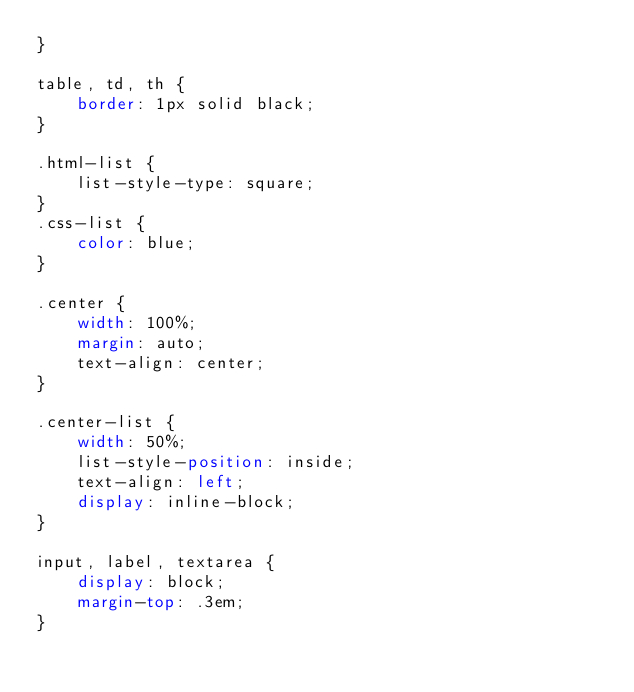Convert code to text. <code><loc_0><loc_0><loc_500><loc_500><_CSS_>}

table, td, th {
    border: 1px solid black;
}

.html-list {
    list-style-type: square;
}
.css-list {
    color: blue;
}

.center {
    width: 100%;
    margin: auto;
    text-align: center;
}

.center-list {
    width: 50%;
    list-style-position: inside;
    text-align: left;
    display: inline-block;
}

input, label, textarea {
    display: block;
    margin-top: .3em;
}
</code> 